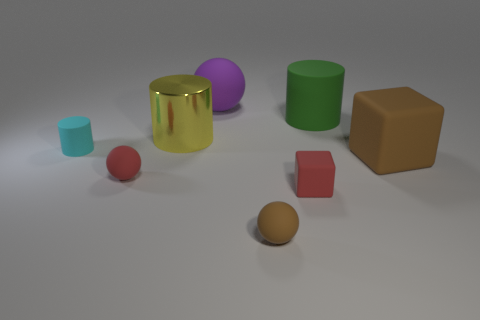Subtract 1 spheres. How many spheres are left? 2 Add 2 red rubber objects. How many objects exist? 10 Subtract all cylinders. How many objects are left? 5 Add 6 tiny red objects. How many tiny red objects are left? 8 Add 7 small cubes. How many small cubes exist? 8 Subtract 0 green cubes. How many objects are left? 8 Subtract all big green rubber cubes. Subtract all big purple rubber objects. How many objects are left? 7 